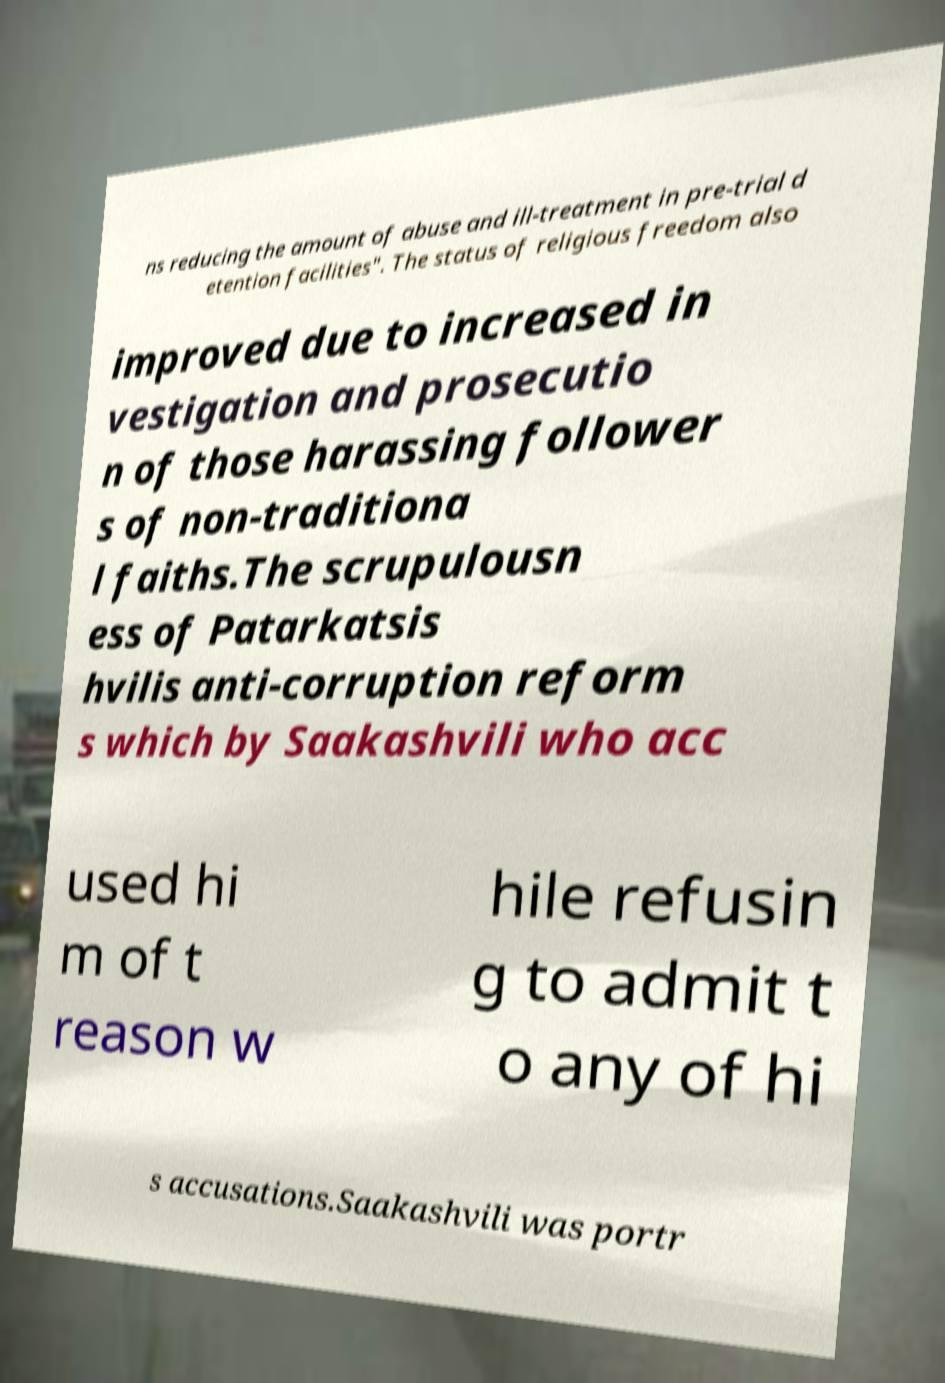Can you read and provide the text displayed in the image?This photo seems to have some interesting text. Can you extract and type it out for me? ns reducing the amount of abuse and ill-treatment in pre-trial d etention facilities". The status of religious freedom also improved due to increased in vestigation and prosecutio n of those harassing follower s of non-traditiona l faiths.The scrupulousn ess of Patarkatsis hvilis anti-corruption reform s which by Saakashvili who acc used hi m of t reason w hile refusin g to admit t o any of hi s accusations.Saakashvili was portr 